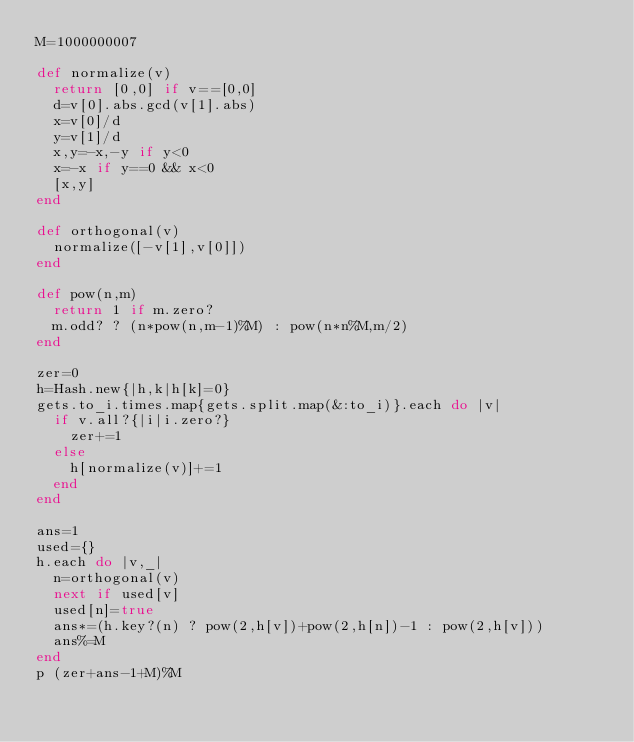<code> <loc_0><loc_0><loc_500><loc_500><_Ruby_>M=1000000007

def normalize(v)
  return [0,0] if v==[0,0]
  d=v[0].abs.gcd(v[1].abs)
  x=v[0]/d
  y=v[1]/d
  x,y=-x,-y if y<0
  x=-x if y==0 && x<0
  [x,y]
end

def orthogonal(v)
  normalize([-v[1],v[0]])
end

def pow(n,m)
  return 1 if m.zero?
  m.odd? ? (n*pow(n,m-1)%M) : pow(n*n%M,m/2)
end

zer=0
h=Hash.new{|h,k|h[k]=0}
gets.to_i.times.map{gets.split.map(&:to_i)}.each do |v|
  if v.all?{|i|i.zero?}
    zer+=1
  else
    h[normalize(v)]+=1
  end
end

ans=1
used={}
h.each do |v,_|
  n=orthogonal(v)
  next if used[v]
  used[n]=true
  ans*=(h.key?(n) ? pow(2,h[v])+pow(2,h[n])-1 : pow(2,h[v]))
  ans%=M
end
p (zer+ans-1+M)%M</code> 